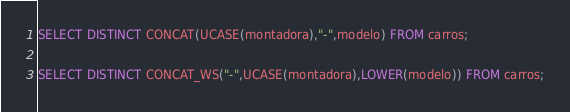<code> <loc_0><loc_0><loc_500><loc_500><_SQL_>SELECT DISTINCT CONCAT(UCASE(montadora),"-",modelo) FROM carros;

SELECT DISTINCT CONCAT_WS("-",UCASE(montadora),LOWER(modelo)) FROM carros;
</code> 